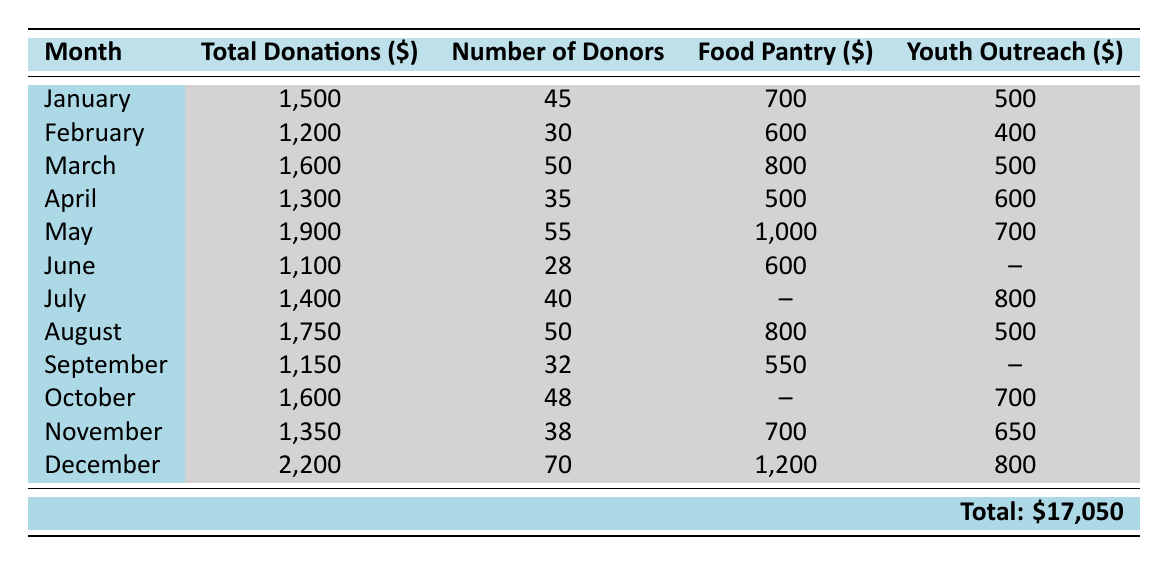What was the total amount collected in December 2023? The table shows that in December 2023, the total donations were listed as 2,200 dollars.
Answer: 2,200 How many donors contributed in March 2023? Referring to the table, March 2023 has 50 listed as the number of donors.
Answer: 50 What is the average amount donated to the Food Pantry from January to March 2023? The amounts donated to the Food Pantry are 700 (January) + 600 (February) + 800 (March) = 2,100. There are three months, so the average is 2,100 / 3 = 700.
Answer: 700 Did the total donations exceed 1,800 dollars in any month of 2023? Looking through the total donations, only December (2,200), May (1,900), and October (1,600) exceed 1,800 dollars, thereby confirming yes.
Answer: Yes What was the total amount donated to the Youth Outreach program in 2023? The donations for Youth Outreach are as follows: 500 (January) + 400 (February) + 500 (March) + 600 (April) + 700 (May) + 800 (July) + 500 (August) + 700 (October) + 650 (November) + 800 (December) = 5,150.
Answer: 5,150 Calculate the difference in the number of donors between the highest and lowest months in 2023. The highest number of donors is 70 in December and the lowest is 28 in June. The difference is 70 - 28 = 42.
Answer: 42 Which month had the highest total donations and what was the amount? Looking at the table, December has the highest total donations at 2,200 dollars.
Answer: December (2,200) Was the amount donated to the Senior Assistance program higher in August than in February? Checking the amounts, August received 450 and February received 200, indicating that August was indeed higher.
Answer: Yes How much was the total donations in the second half of the year (July to December)? The total donations from July (1,400), August (1,750), September (1,150), October (1,600), November (1,350), and December (2,200) are calculated as 1,400 + 1,750 + 1,150 + 1,600 + 1,350 + 2,200 = 9,450.
Answer: 9,450 What percentage of the total donations in the year went to the Food Pantry? The total donations for the year is 17,050 dollars, and the amount donated to Food Pantry is 700 + 600 + 800 + 500 + 1,000 + 600 + 800 + 550 + 1,200 = 6,300. The percentage is (6,300 / 17,050) * 100 ≈ 36.9%.
Answer: 36.9% 